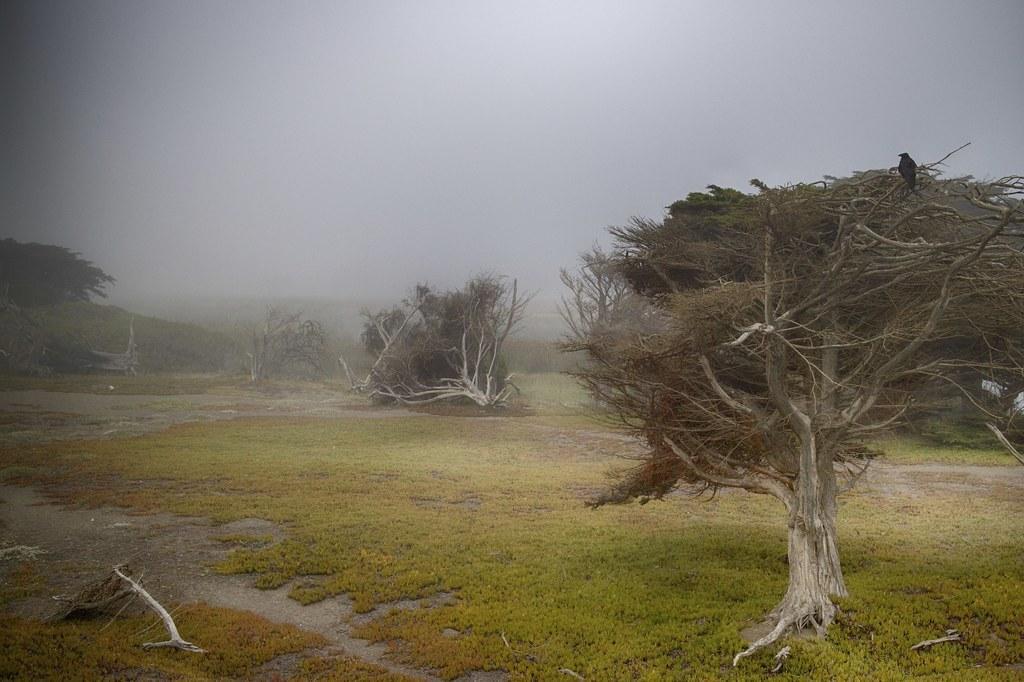Could you give a brief overview of what you see in this image? In the picture I can see trees and the grass. In the background I can see the sky. 